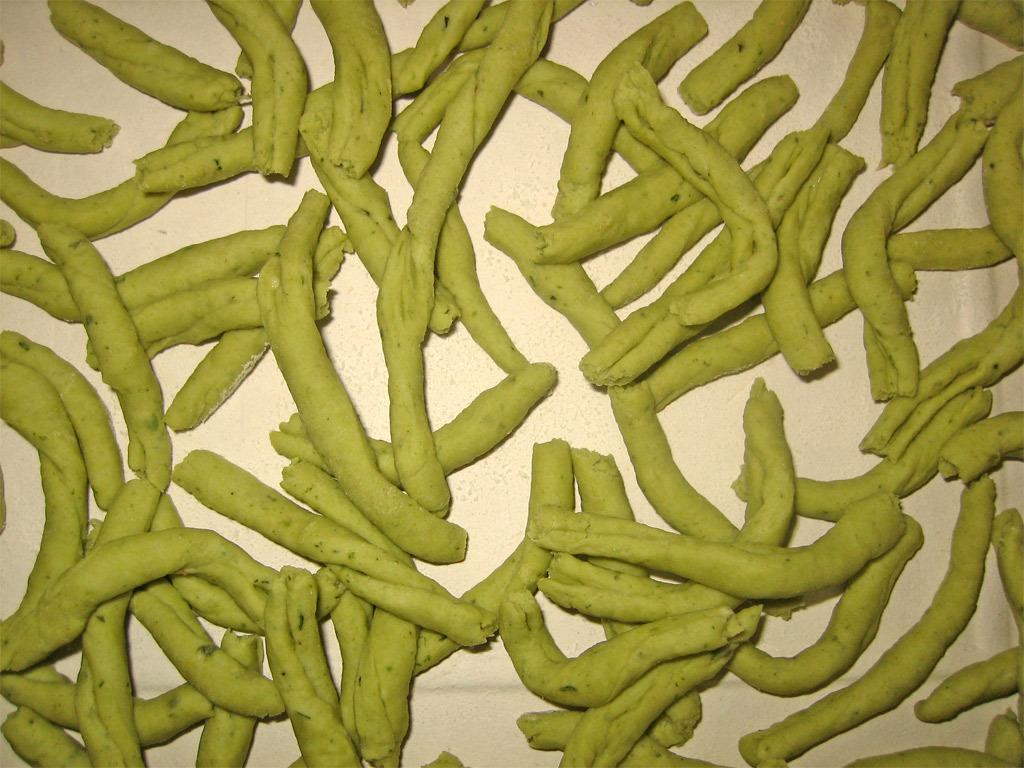In one or two sentences, can you explain what this image depicts? In this image we can see a food item. 